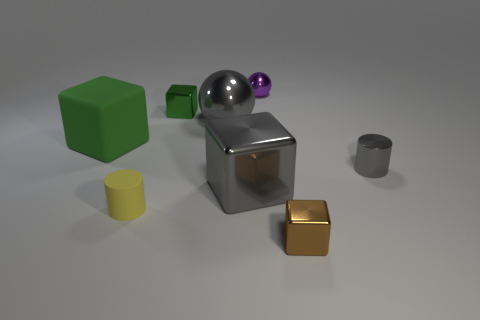Subtract all brown metal cubes. How many cubes are left? 3 Add 2 green matte objects. How many objects exist? 10 Subtract 3 blocks. How many blocks are left? 1 Subtract all yellow cylinders. How many cylinders are left? 1 Subtract all cylinders. How many objects are left? 6 Subtract all blue blocks. Subtract all purple cylinders. How many blocks are left? 4 Subtract all yellow spheres. How many cyan cylinders are left? 0 Subtract all large balls. Subtract all tiny gray metal cylinders. How many objects are left? 6 Add 1 big gray metal cubes. How many big gray metal cubes are left? 2 Add 8 gray metallic cylinders. How many gray metallic cylinders exist? 9 